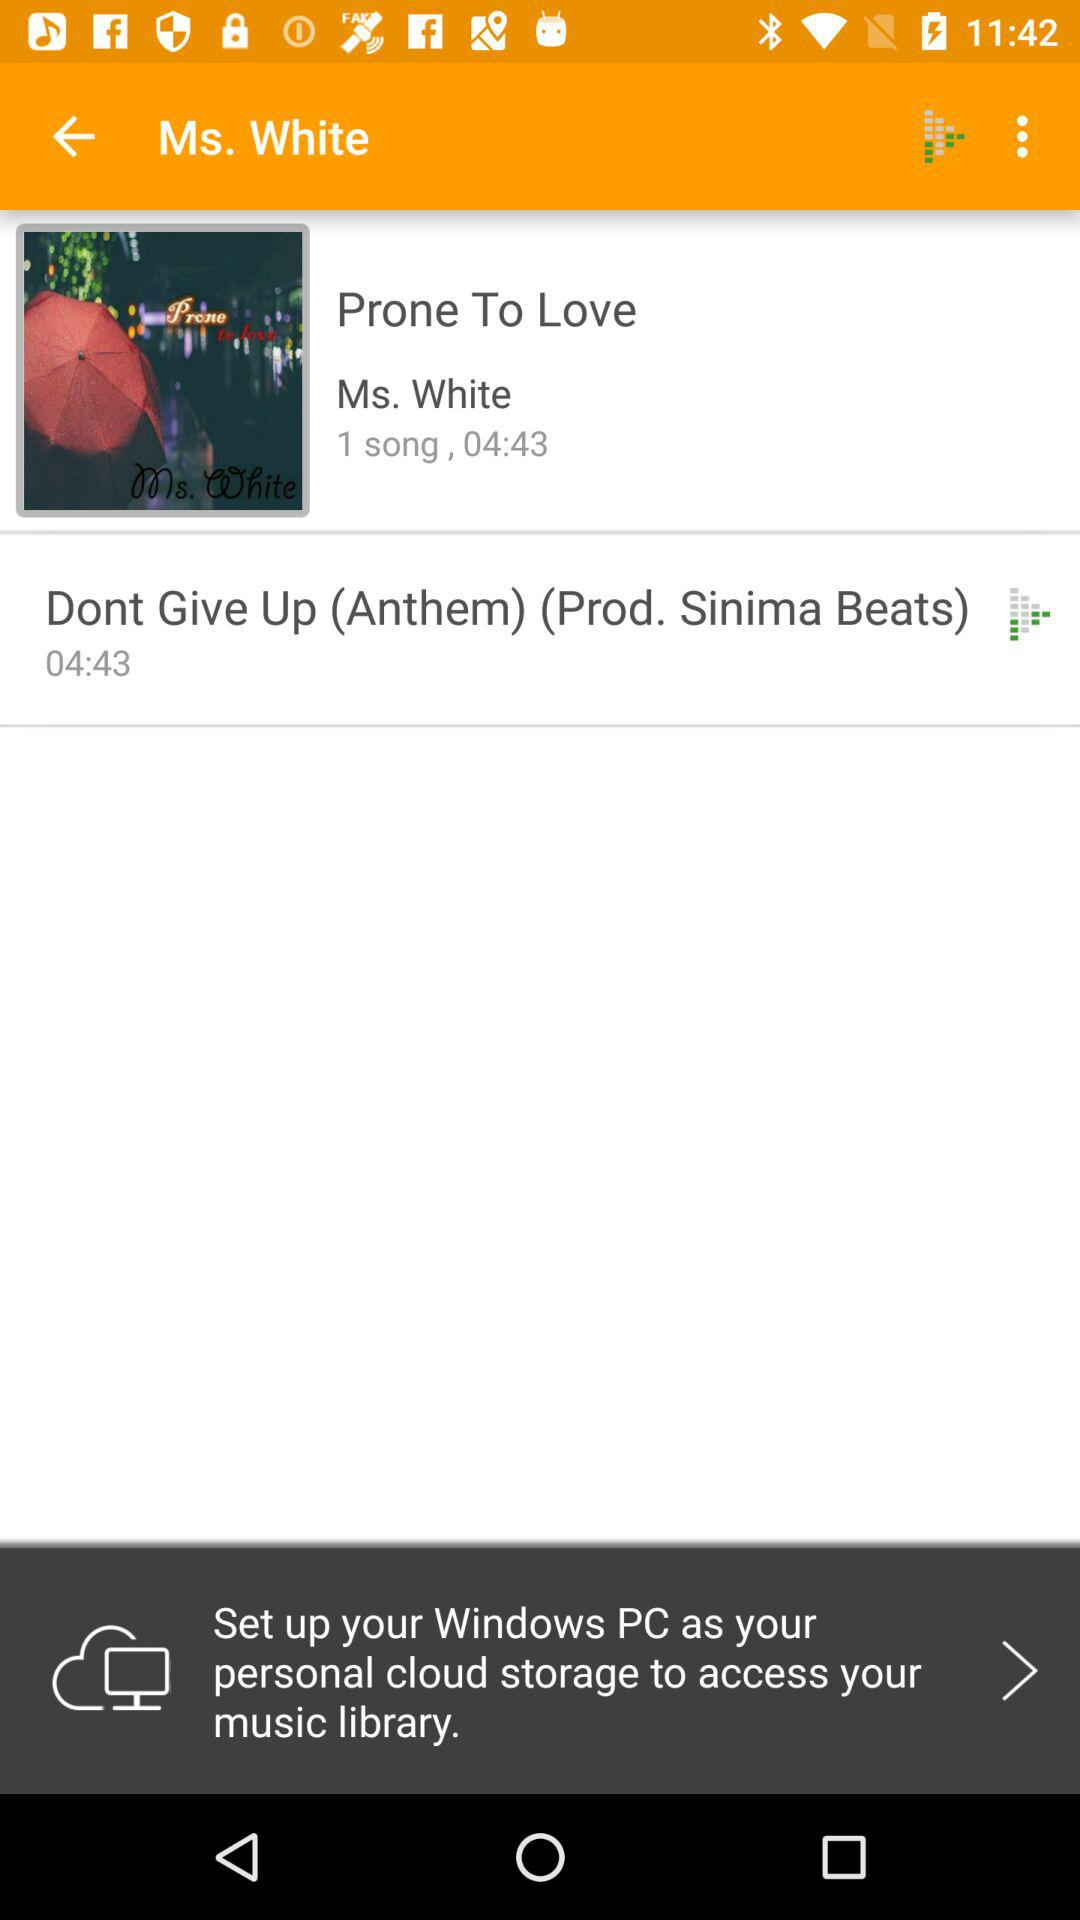Which song was played before "Prone To Love"?
When the provided information is insufficient, respond with <no answer>. <no answer> 